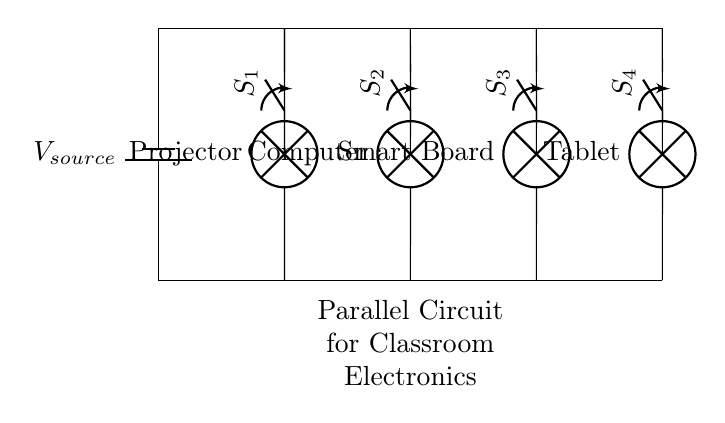What is the voltage source in this circuit? The voltage source in the diagram is indicated as V_source, which provides the potential difference for the entire circuit.
Answer: V_source How many devices are present in the circuit? By counting the components labeled as Projector, Computer, Smart Board, and Tablet, we find that there are four devices connected in parallel.
Answer: Four What is the purpose of the switches in this circuit? The switches are used to control the individual devices, allowing them to be turned on or off without affecting the other devices in the parallel circuit.
Answer: Control If all devices are turned on, what is the total voltage across each device? In a parallel circuit, each device receives the same voltage as the source, which is V_source. Therefore, the voltage across each device remains uniform irrespective of the number of devices.
Answer: V_source Which device is connected to the first switch? The first switch, labeled S1, is connected to the Projector, allowing it to be controlled independently from the other devices.
Answer: Projector Explain how the current behaves in this parallel circuit. In a parallel circuit, the total current splits across all devices. Each device receives the same voltage from the source and the current through each device can vary based on its resistance, while the total current is the sum of the currents through each branch.
Answer: Splits 